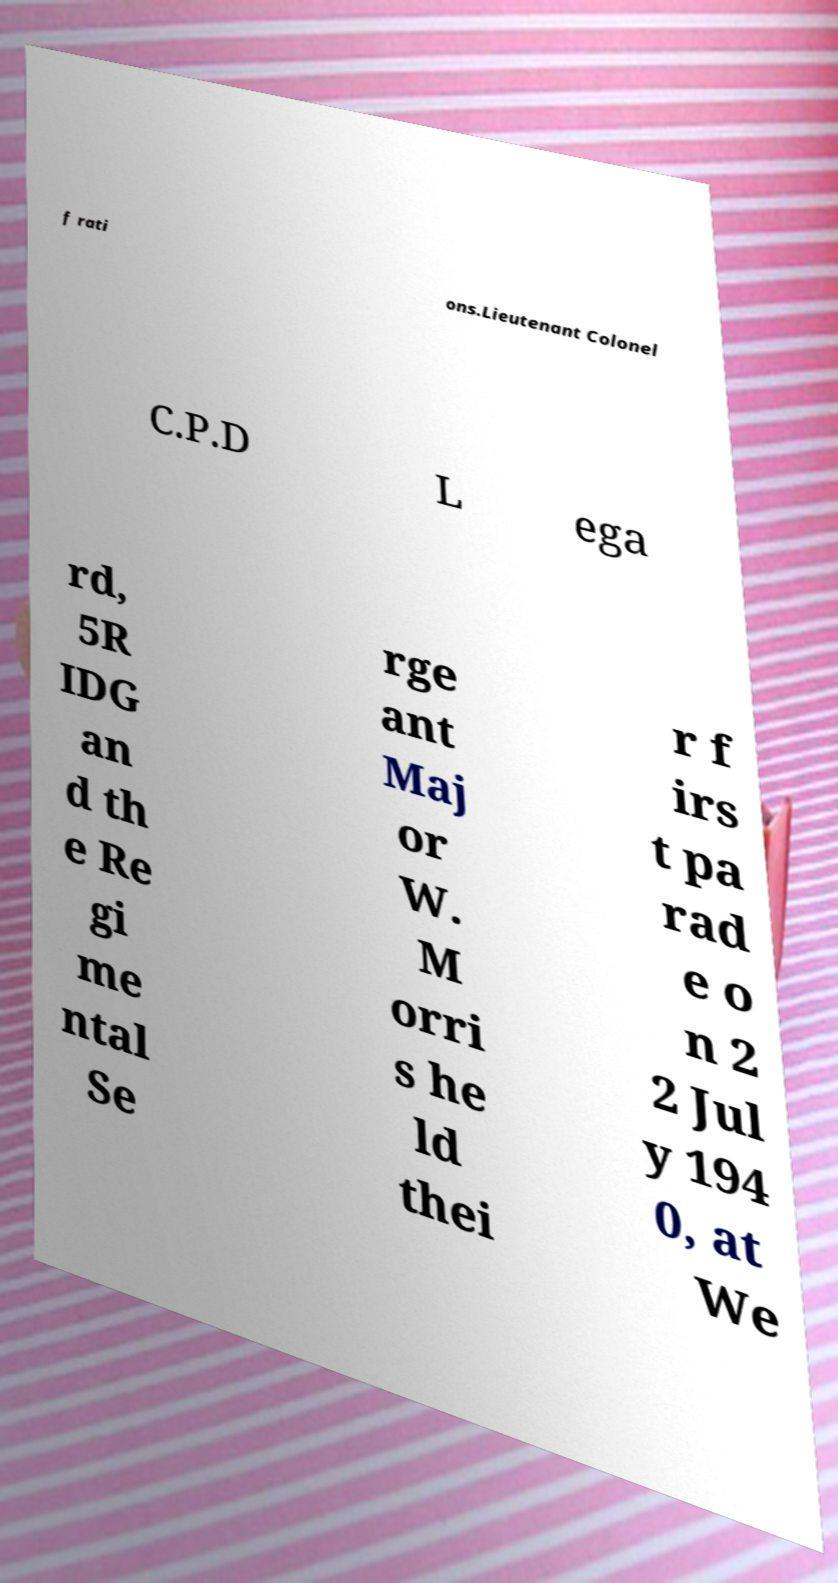There's text embedded in this image that I need extracted. Can you transcribe it verbatim? f rati ons.Lieutenant Colonel C.P.D L ega rd, 5R IDG an d th e Re gi me ntal Se rge ant Maj or W. M orri s he ld thei r f irs t pa rad e o n 2 2 Jul y 194 0, at We 